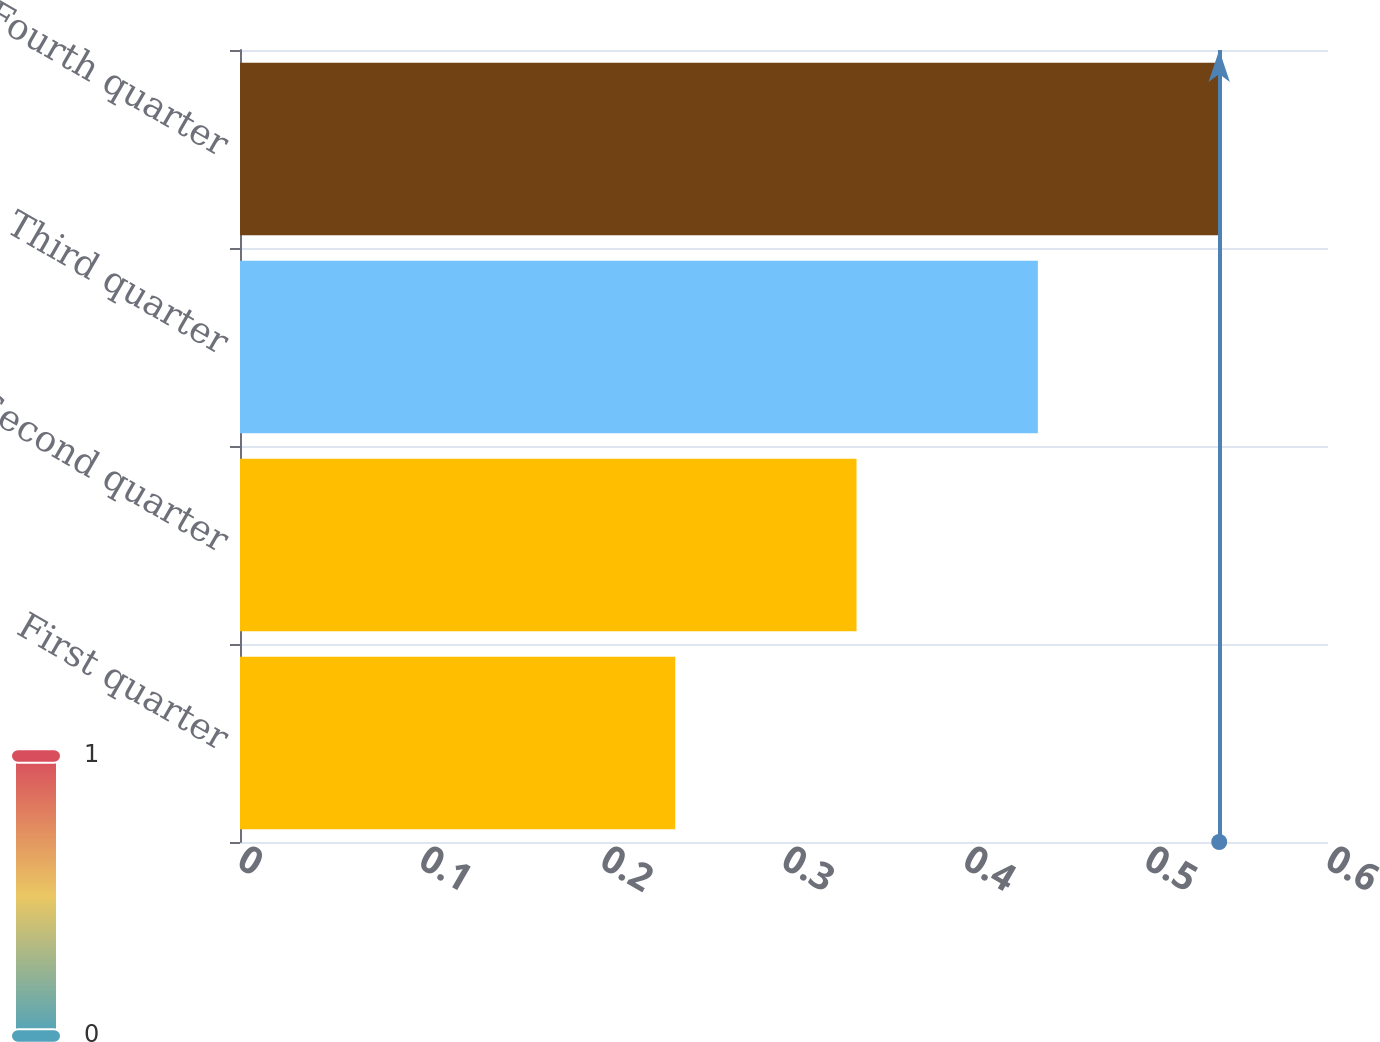<chart> <loc_0><loc_0><loc_500><loc_500><bar_chart><fcel>First quarter<fcel>Second quarter<fcel>Third quarter<fcel>Fourth quarter<nl><fcel>0.24<fcel>0.34<fcel>0.44<fcel>0.54<nl></chart> 